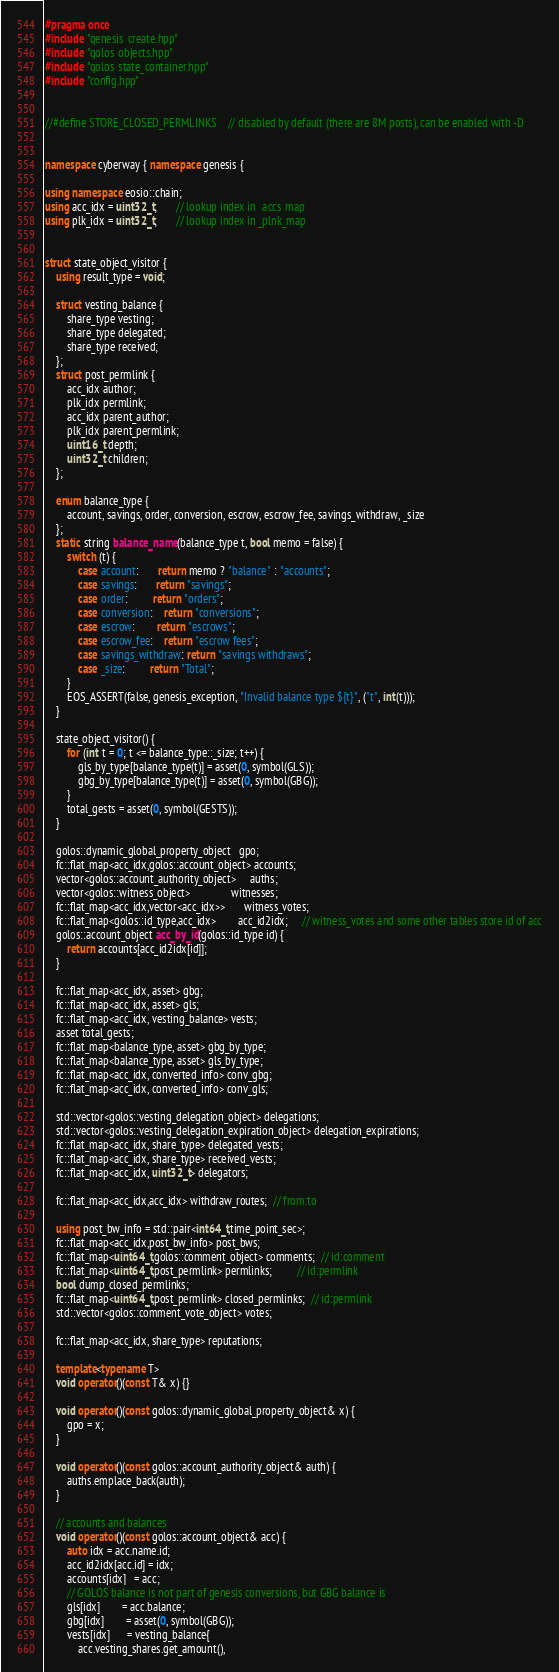Convert code to text. <code><loc_0><loc_0><loc_500><loc_500><_C++_>#pragma once
#include "genesis_create.hpp"
#include "golos_objects.hpp"
#include "golos_state_container.hpp"
#include "config.hpp"


//#define STORE_CLOSED_PERMLINKS    // disabled by default (there are 8M posts), can be enabled with -D


namespace cyberway { namespace genesis {

using namespace eosio::chain;
using acc_idx = uint32_t;       // lookup index in _accs_map
using plk_idx = uint32_t;       // lookup index in _plnk_map


struct state_object_visitor {
    using result_type = void;

    struct vesting_balance {
        share_type vesting;
        share_type delegated;
        share_type received;
    };
    struct post_permlink {
        acc_idx author;
        plk_idx permlink;
        acc_idx parent_author;
        plk_idx parent_permlink;
        uint16_t depth;
        uint32_t children;
    };

    enum balance_type {
        account, savings, order, conversion, escrow, escrow_fee, savings_withdraw, _size
    };
    static string balance_name(balance_type t, bool memo = false) {
        switch (t) {
            case account:       return memo ? "balance" : "accounts";
            case savings:       return "savings";
            case order:         return "orders";
            case conversion:    return "conversions";
            case escrow:        return "escrows";
            case escrow_fee:    return "escrow fees";
            case savings_withdraw: return "savings withdraws";
            case _size:         return "Total";
        }
        EOS_ASSERT(false, genesis_exception, "Invalid balance type ${t}", ("t", int(t)));
    }

    state_object_visitor() {
        for (int t = 0; t <= balance_type::_size; t++) {
            gls_by_type[balance_type(t)] = asset(0, symbol(GLS));
            gbg_by_type[balance_type(t)] = asset(0, symbol(GBG));
        }
        total_gests = asset(0, symbol(GESTS));
    }

    golos::dynamic_global_property_object   gpo;
    fc::flat_map<acc_idx,golos::account_object> accounts;
    vector<golos::account_authority_object>     auths;
    vector<golos::witness_object>               witnesses;
    fc::flat_map<acc_idx,vector<acc_idx>>       witness_votes;
    fc::flat_map<golos::id_type,acc_idx>        acc_id2idx;     // witness_votes and some other tables store id of acc
    golos::account_object acc_by_id(golos::id_type id) {
        return accounts[acc_id2idx[id]];
    }

    fc::flat_map<acc_idx, asset> gbg;
    fc::flat_map<acc_idx, asset> gls;
    fc::flat_map<acc_idx, vesting_balance> vests;
    asset total_gests;
    fc::flat_map<balance_type, asset> gbg_by_type;
    fc::flat_map<balance_type, asset> gls_by_type;
    fc::flat_map<acc_idx, converted_info> conv_gbg;
    fc::flat_map<acc_idx, converted_info> conv_gls;

    std::vector<golos::vesting_delegation_object> delegations;
    std::vector<golos::vesting_delegation_expiration_object> delegation_expirations;
    fc::flat_map<acc_idx, share_type> delegated_vests;
    fc::flat_map<acc_idx, share_type> received_vests;
    fc::flat_map<acc_idx, uint32_t> delegators;

    fc::flat_map<acc_idx,acc_idx> withdraw_routes;  // from:to

    using post_bw_info = std::pair<int64_t,time_point_sec>;
    fc::flat_map<acc_idx,post_bw_info> post_bws;
    fc::flat_map<uint64_t,golos::comment_object> comments;  // id:comment
    fc::flat_map<uint64_t,post_permlink> permlinks;         // id:permlink
    bool dump_closed_permlinks;
    fc::flat_map<uint64_t,post_permlink> closed_permlinks;  // id:permlink
    std::vector<golos::comment_vote_object> votes;

    fc::flat_map<acc_idx, share_type> reputations;

    template<typename T>
    void operator()(const T& x) {}

    void operator()(const golos::dynamic_global_property_object& x) {
        gpo = x;
    }

    void operator()(const golos::account_authority_object& auth) {
        auths.emplace_back(auth);
    }

    // accounts and balances
    void operator()(const golos::account_object& acc) {
        auto idx = acc.name.id;
        acc_id2idx[acc.id] = idx;
        accounts[idx]   = acc;
        // GOLOS balance is not part of genesis conversions, but GBG balance is
        gls[idx]        = acc.balance;
        gbg[idx]        = asset(0, symbol(GBG));
        vests[idx]      = vesting_balance{
            acc.vesting_shares.get_amount(),</code> 